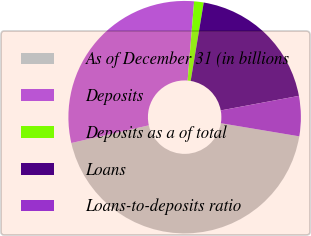Convert chart. <chart><loc_0><loc_0><loc_500><loc_500><pie_chart><fcel>As of December 31 (in billions<fcel>Deposits<fcel>Deposits as a of total<fcel>Loans<fcel>Loans-to-deposits ratio<nl><fcel>43.79%<fcel>29.87%<fcel>1.33%<fcel>19.44%<fcel>5.57%<nl></chart> 